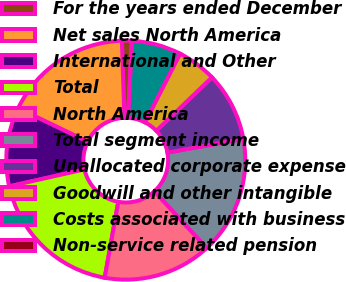Convert chart to OTSL. <chart><loc_0><loc_0><loc_500><loc_500><pie_chart><fcel>For the years ended December<fcel>Net sales North America<fcel>International and Other<fcel>Total<fcel>North America<fcel>Total segment income<fcel>Unallocated corporate expense<fcel>Goodwill and other intangible<fcel>Costs associated with business<fcel>Non-service related pension<nl><fcel>1.34%<fcel>17.33%<fcel>10.67%<fcel>18.66%<fcel>14.67%<fcel>16.0%<fcel>9.33%<fcel>5.33%<fcel>6.67%<fcel>0.0%<nl></chart> 